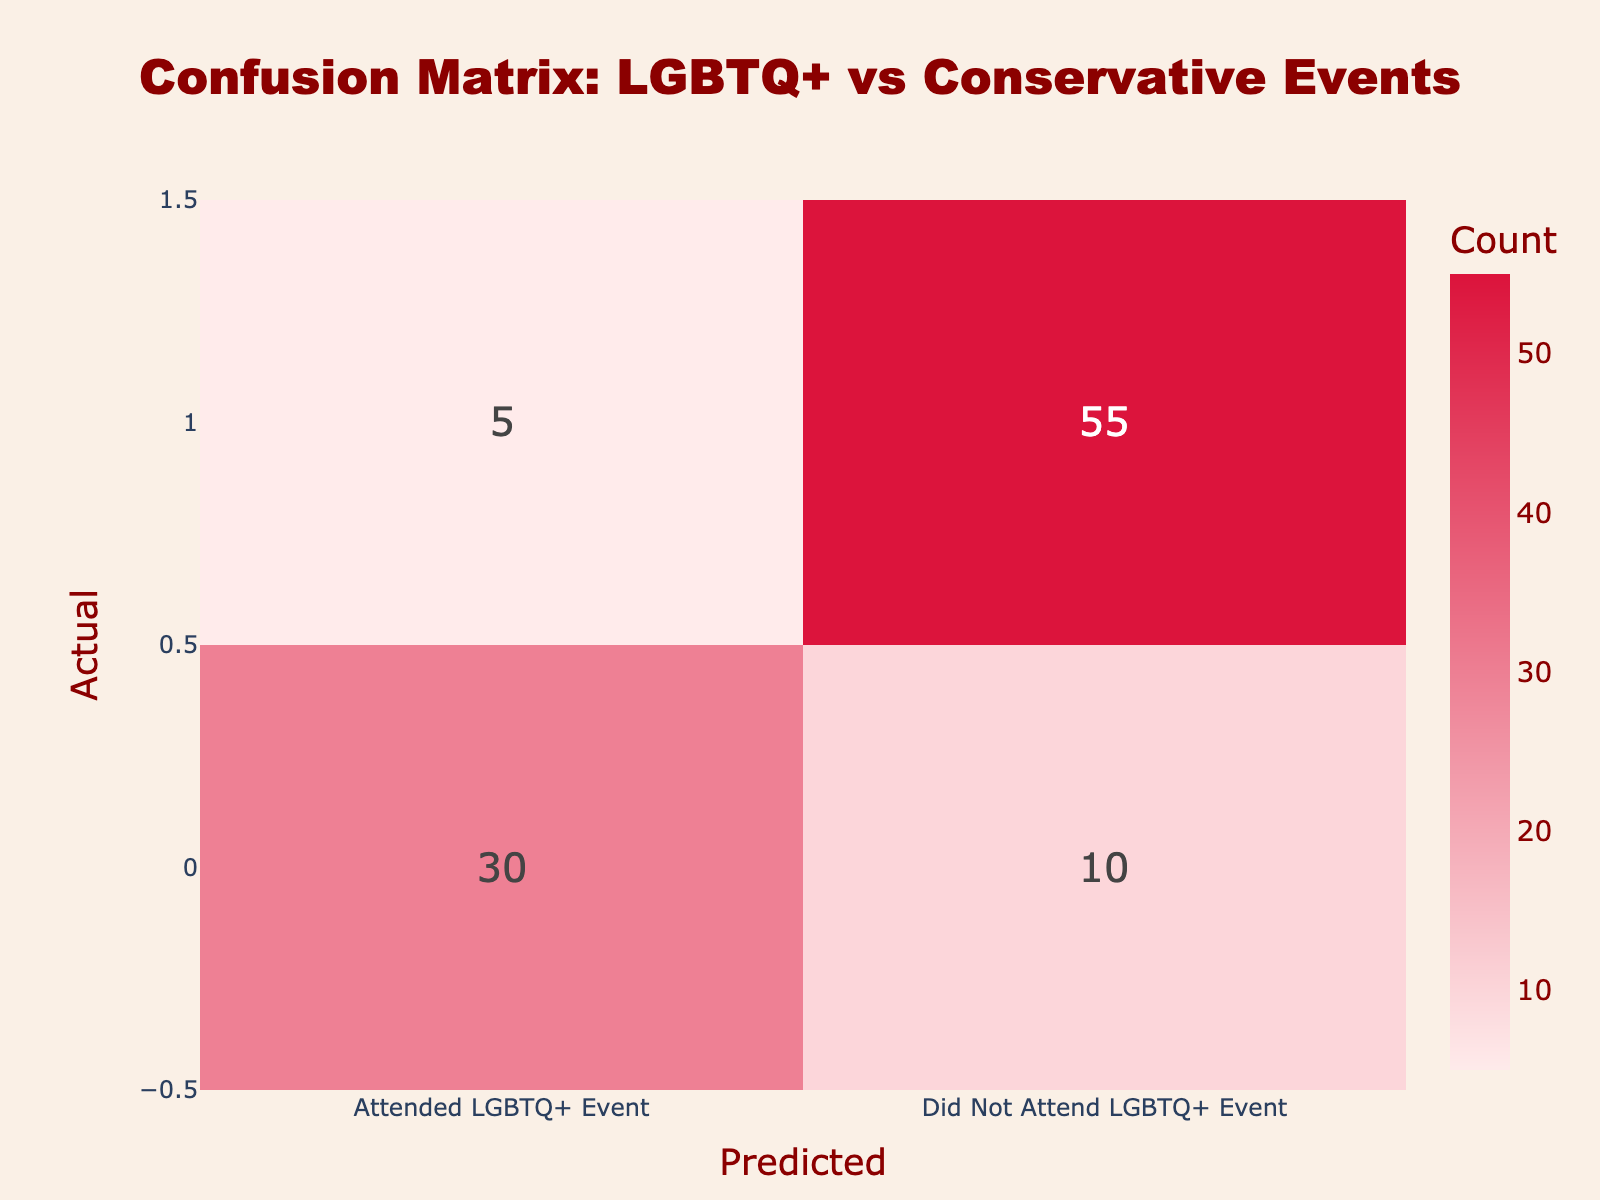What is the number of individuals who attended both an LGBTQ+ event and a conservative event? According to the table, there are 30 individuals who attended both an LGBTQ+ event and a conservative event, as shown in the "Attended Conservative Event" row under the "Attended LGBTQ+ Event" column.
Answer: 30 What is the total number of individuals who did not attend a conservative event? To find the total number of individuals who did not attend a conservative event, we look at the "Did Not Attend Conservative Event" row, which has two values: 5 (who attended an LGBTQ+ event) and 55 (who did not attend an LGBTQ+ event). So, we total these values: 5 + 55 = 60.
Answer: 60 Is it true that more people attended conservative events than those who did not attend LGBTQ+ events? To answer this, we compare the total of the "Attended Conservative Event" row (30 + 10 = 40) with the total of the "Did Not Attend LGBTQ+ Event" column (10 + 55 = 65). Since 40 is less than 65, it is false that more people attended conservative events.
Answer: No What is the percentage of individuals who attended a conservative event and also attended an LGBTQ+ event? To calculate the percentage, take the number of individuals who attended both events (30) and divide it by the total number of individuals (40, calculated from 30 + 10 from the conservative events). So, the percentage is (30/40) * 100 = 75%.
Answer: 75% What is the difference in the number of individuals who attended an LGBTQ+ event and conservative event versus those who did not attend any of these events? The number of individuals who attended both events is 30, and those who did not attend either event can be calculated by looking at the "Did Not Attend Conservative Event" row for non-participants (55). Therefore, the difference is 30 (attended) - 55 (did not attend) = -25.
Answer: -25 How many individuals attended conservative events but did not attend LGBTQ+ events? The table shows that 10 individuals attended conservative events but did not attend LGBTQ+ events, as indicated in the "Did Not Attend LGBTQ+ Event" column under the "Attended Conservative Event" row.
Answer: 10 